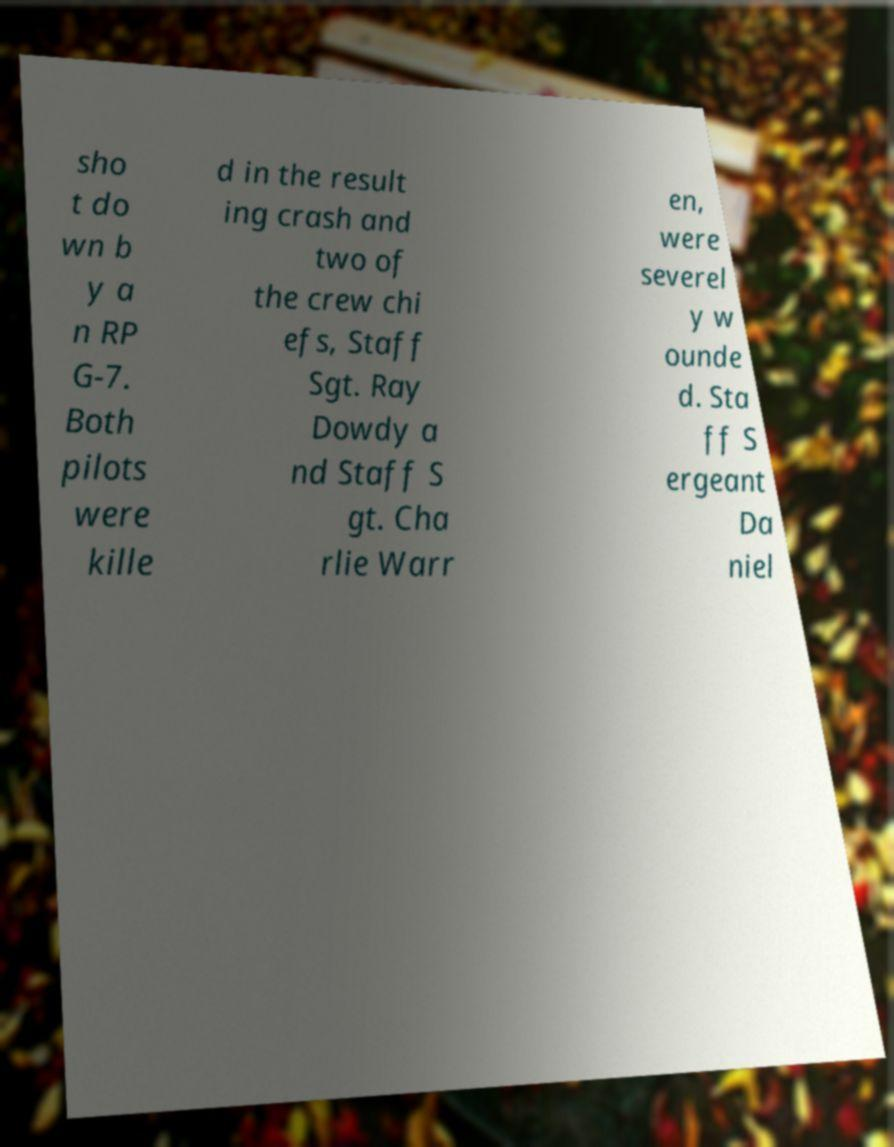For documentation purposes, I need the text within this image transcribed. Could you provide that? sho t do wn b y a n RP G-7. Both pilots were kille d in the result ing crash and two of the crew chi efs, Staff Sgt. Ray Dowdy a nd Staff S gt. Cha rlie Warr en, were severel y w ounde d. Sta ff S ergeant Da niel 